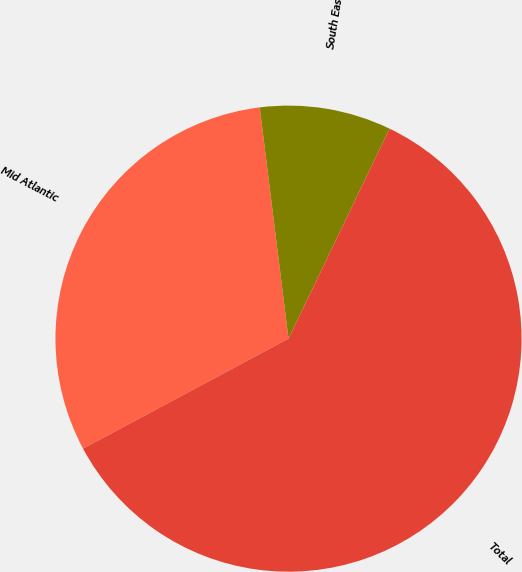Convert chart to OTSL. <chart><loc_0><loc_0><loc_500><loc_500><pie_chart><fcel>Mid Atlantic<fcel>South East<fcel>Total<nl><fcel>30.85%<fcel>9.11%<fcel>60.04%<nl></chart> 